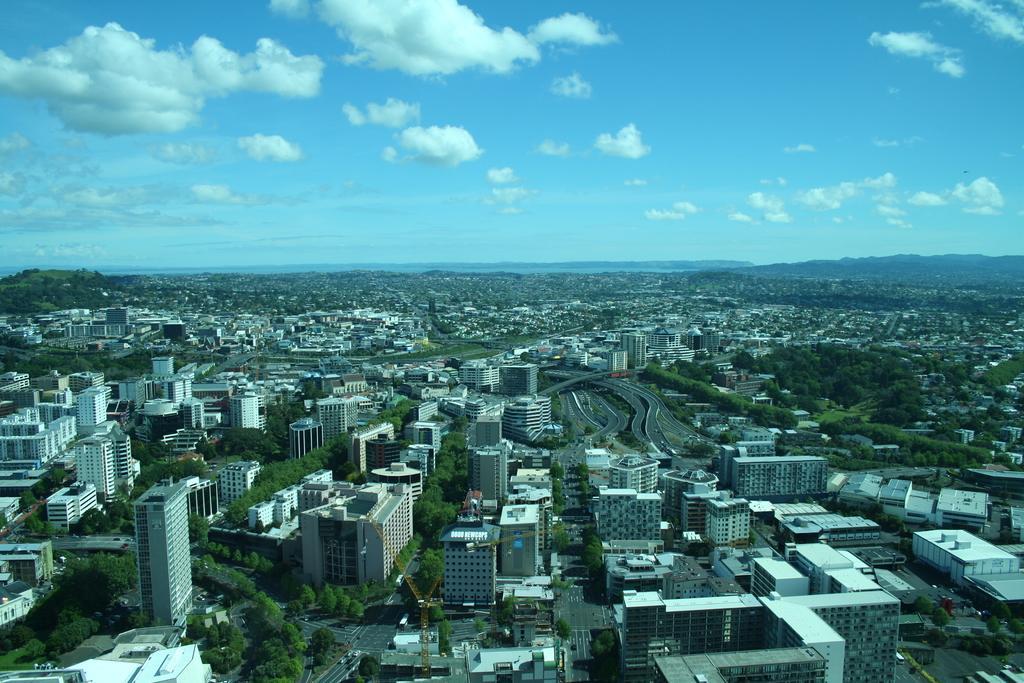Please provide a concise description of this image. In this picture we can see there are buildings, houses, trees and some vehicles on the road. Behind the buildings there are hills and the sky. 